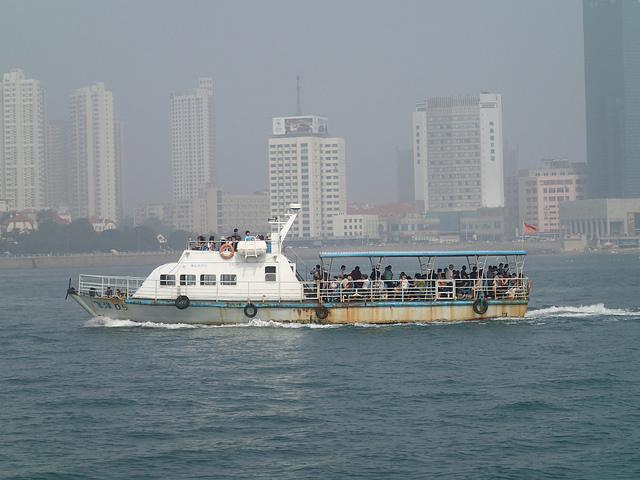Where are the people on the boat ultimately headed?

Choices:
A) mexico city
B) thailand
C) near shore
D) laguardia near shore 